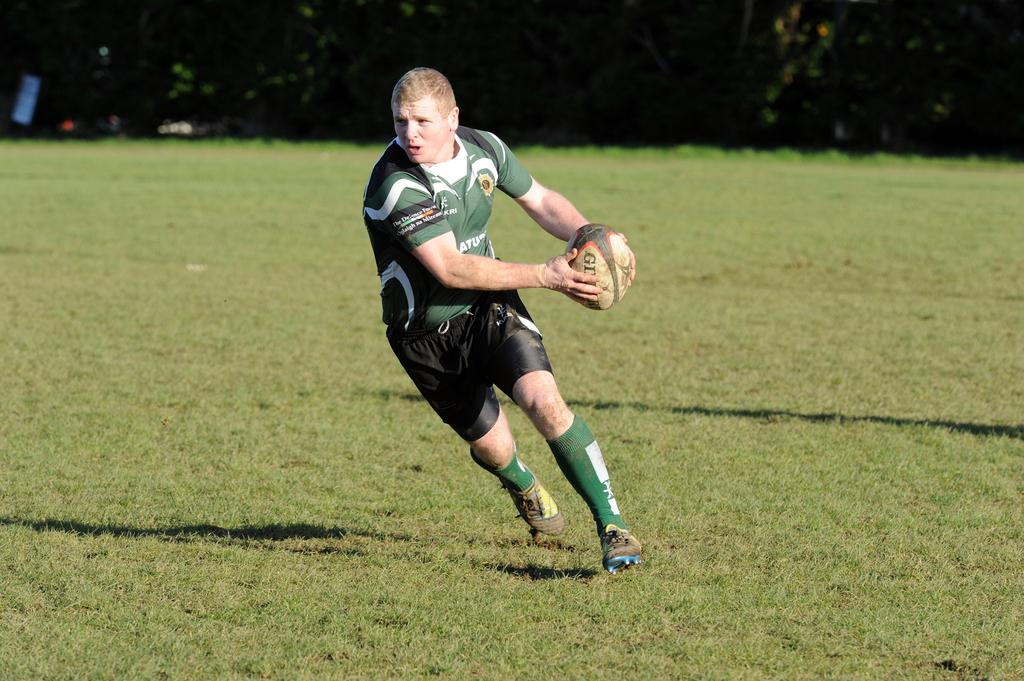What is the person in the image doing? There is a person running in the image. What is the person holding while running? The person is holding a ball. What type of surface is visible in the image? There is grass visible in the image. What other natural elements can be seen in the image? There are trees in the image. What type of needle can be seen in the image? There is no needle present in the image. What shape is the hill in the image? There is no hill present in the image. 